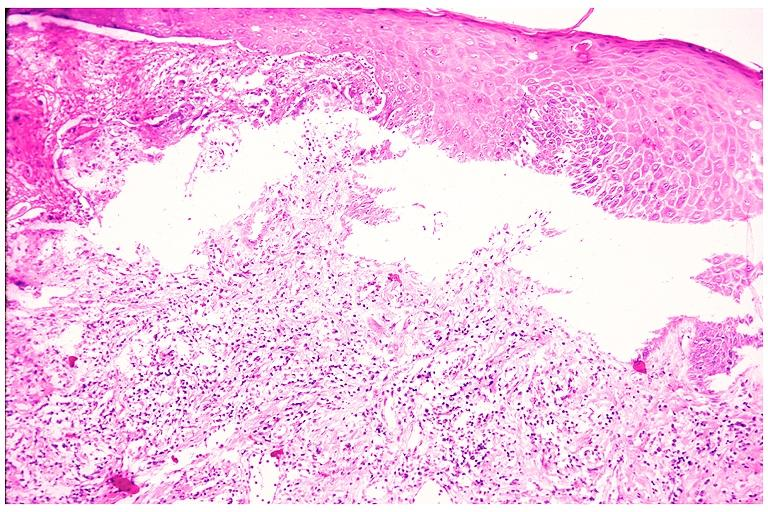what is present?
Answer the question using a single word or phrase. Oral 